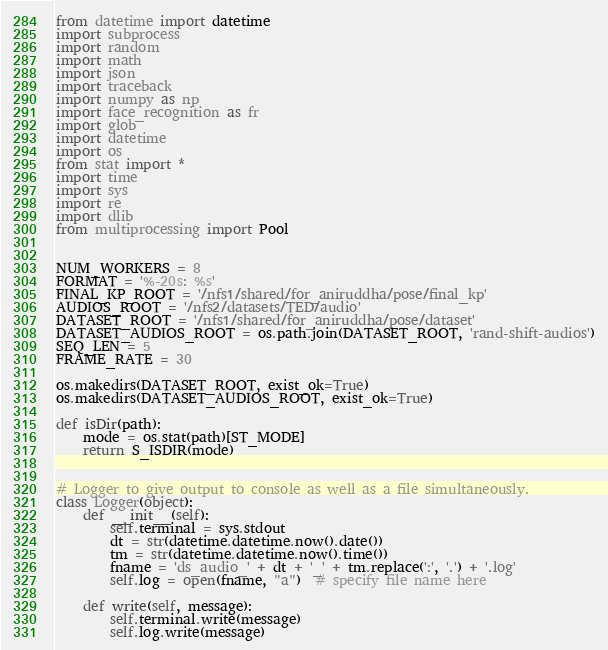<code> <loc_0><loc_0><loc_500><loc_500><_Python_>from datetime import datetime
import subprocess
import random
import math
import json
import traceback
import numpy as np
import face_recognition as fr
import glob
import datetime
import os
from stat import *
import time
import sys
import re
import dlib
from multiprocessing import Pool


NUM_WORKERS = 8
FORMAT = '%-20s: %s'
FINAL_KP_ROOT = '/nfs1/shared/for_aniruddha/pose/final_kp'
AUDIOS_ROOT = '/nfs2/datasets/TED/audio'
DATASET_ROOT = '/nfs1/shared/for_aniruddha/pose/dataset'
DATASET_AUDIOS_ROOT = os.path.join(DATASET_ROOT, 'rand-shift-audios')
SEQ_LEN = 5
FRAME_RATE = 30

os.makedirs(DATASET_ROOT, exist_ok=True)
os.makedirs(DATASET_AUDIOS_ROOT, exist_ok=True)

def isDir(path):
    mode = os.stat(path)[ST_MODE]
    return S_ISDIR(mode)


# Logger to give output to console as well as a file simultaneously.
class Logger(object):
    def __init__(self):
        self.terminal = sys.stdout
        dt = str(datetime.datetime.now().date())
        tm = str(datetime.datetime.now().time())
        fname = 'ds_audio_' + dt + '_' + tm.replace(':', '.') + '.log'
        self.log = open(fname, "a")  # specify file name here

    def write(self, message):
        self.terminal.write(message)
        self.log.write(message)
</code> 